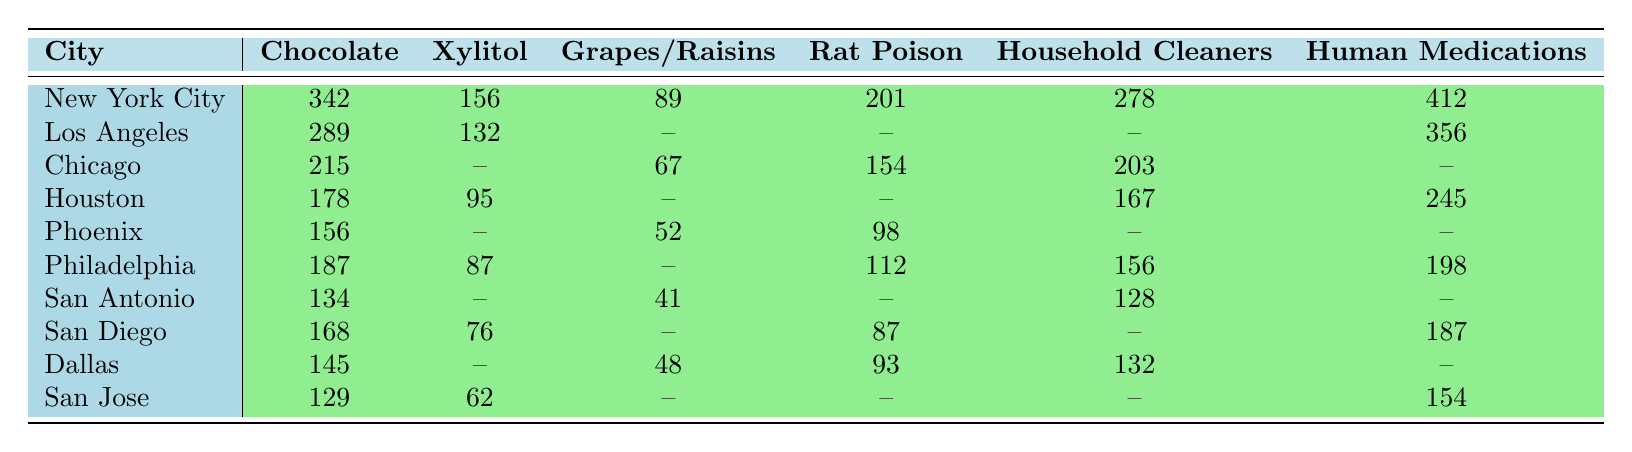What city reported the highest number of cases of chocolate poisoning? By reviewing the chocolate poisoning cases for each city in the table, New York City has 342 cases, which is more than any other city listed.
Answer: New York City How many cases of Xylitol poisoning were reported in San Diego? Referring to the table, San Diego reported 76 cases of Xylitol poisoning.
Answer: 76 Which toxin had the fewest reported cases in Houston, and how many cases were there? In Houston, the toxin with the fewest cases is Onions/Garlic, with 58 cases reported.
Answer: Onions/Garlic; 58 What is the total number of cases for human medications across all cities? Adding up the human medication cases from each city: 412 (NYC) + 356 (LA) + 245 (Houston) + 198 (Philadelphia) + 187 (San Diego) + 154 (San Jose) = 1552 total cases.
Answer: 1552 Is there any city that reported cases of grapes/raisins poisoning? Yes, Chicago and Phoenix reported cases. Chicago had 67 cases and Phoenix had 52 cases.
Answer: Yes Which cities reported cases of rat poison? The cities that reported rat poison cases include New York City, Chicago, Houston, Phoenix, Philadelphia, San Diego, and Dallas.
Answer: 7 cities What is the sum of chocolate poisoning cases in Phoenix, San Antonio, and San Jose? The chocolate cases are 156 (Phoenix) + 134 (San Antonio) + 129 (San Jose) = 419.
Answer: 419 How does the number of reported household cleaner poisoning cases in New York City compare to that in San Antonio? New York City reported 278 cases, while San Antonio reported 128 cases, indicating NYC has 150 more cases.
Answer: NYC has 150 more cases What percentage of poisoning cases in Los Angeles were due to human medications? In Los Angeles, there are 356 human medication cases out of a total of (289 + 132 + 76 + 187 + 98 + 356 = 1138), which calculates to about (356/1138)*100 ≈ 31.3%.
Answer: 31.3% Which city had the highest number of total poisoning cases for the toxins listed? After calculating the sum of all reported cases for each city, New York City has the highest at 342 + 156 + 89 + 201 + 278 + 412 = 1078.
Answer: New York City 